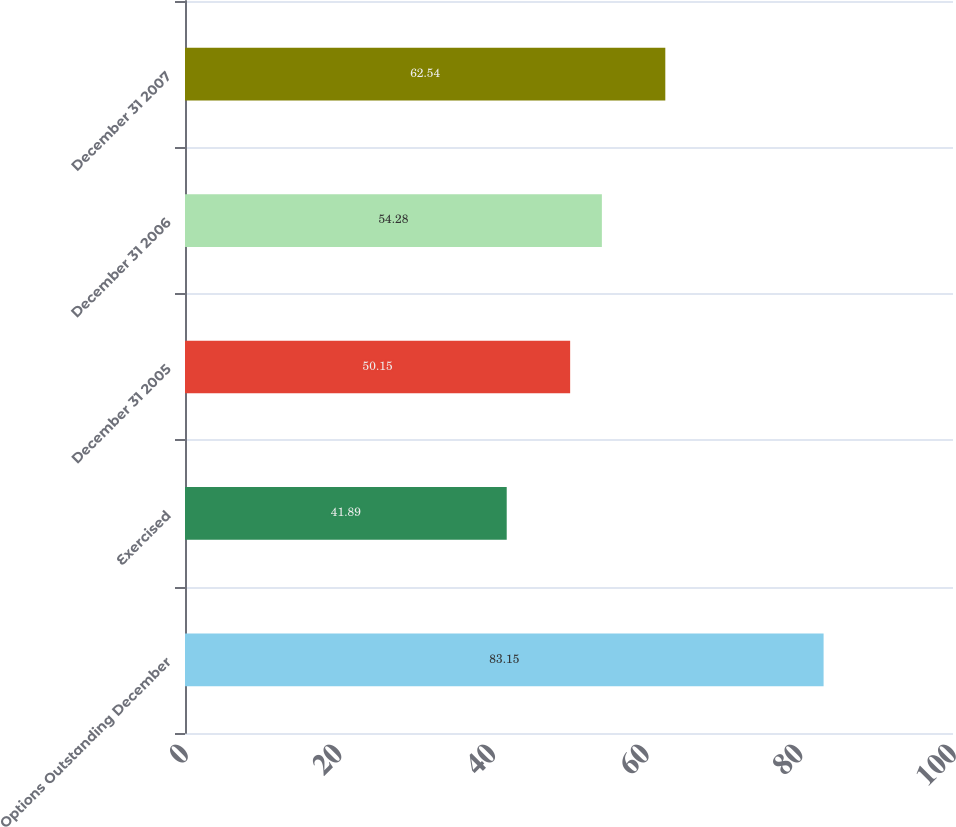<chart> <loc_0><loc_0><loc_500><loc_500><bar_chart><fcel>Options Outstanding December<fcel>Exercised<fcel>December 31 2005<fcel>December 31 2006<fcel>December 31 2007<nl><fcel>83.15<fcel>41.89<fcel>50.15<fcel>54.28<fcel>62.54<nl></chart> 